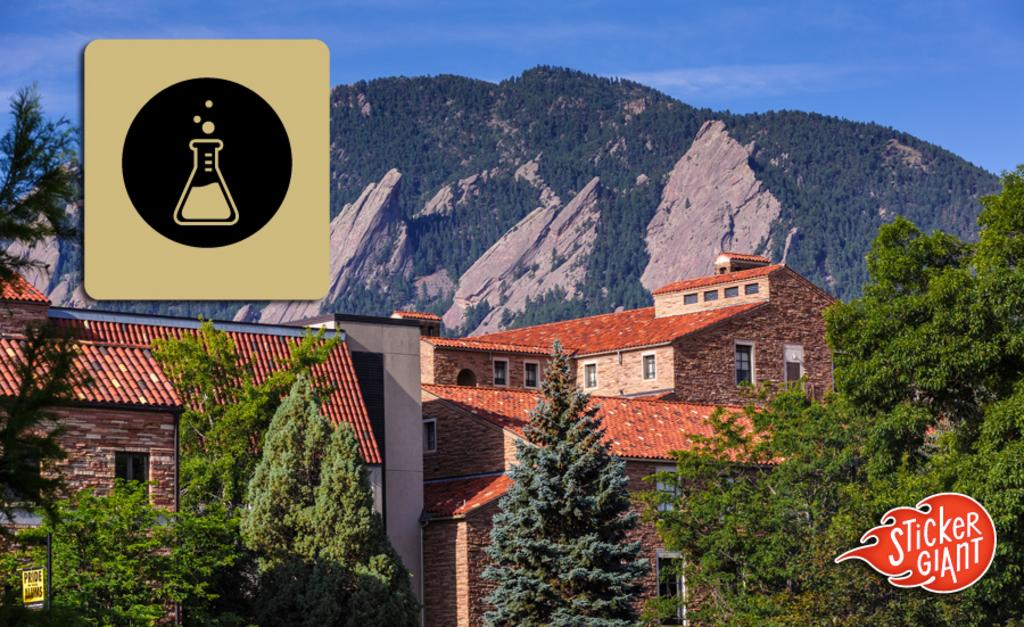What type of natural elements can be seen in the image? There are trees and hills visible in the image. What type of man-made structures are present in the image? There are buildings and a board attached to a pole in the image. What part of the natural environment is visible in the image? The sky is visible in the image. What type of water feature can be seen in the image? There is water visible in the image. What type of books are being read by the trees in the image? There are no books present in the image; it features trees, buildings, a board, hills, sky, and water. What is the opinion of the watermarks on the image? The watermarks on the image are not expressing an opinion, as they are simply marks on the image. 